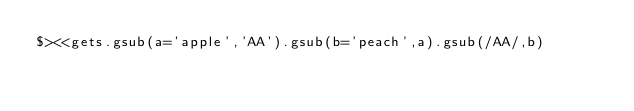<code> <loc_0><loc_0><loc_500><loc_500><_Ruby_>$><<gets.gsub(a='apple','AA').gsub(b='peach',a).gsub(/AA/,b)</code> 